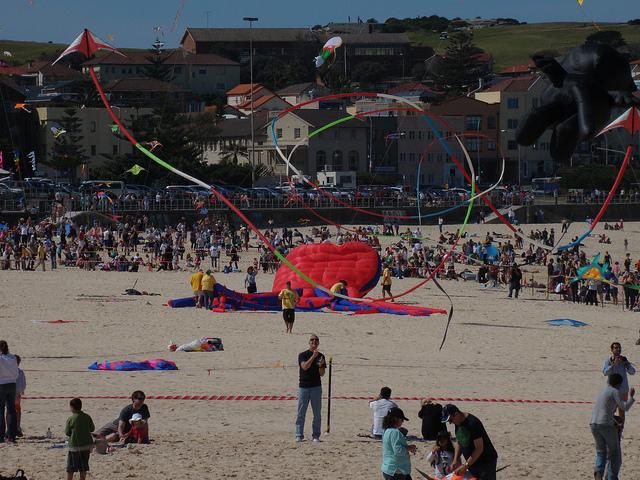What is in the air moving?
Keep it brief. Kites. Where was the picture taken?
Write a very short answer. Beach. What is in the air?
Be succinct. Kites. Is the sun in front or behind the majority of these people?
Be succinct. Front. Where is the this?
Short answer required. Beach. Do a lot of people have jackets on?
Write a very short answer. No. 